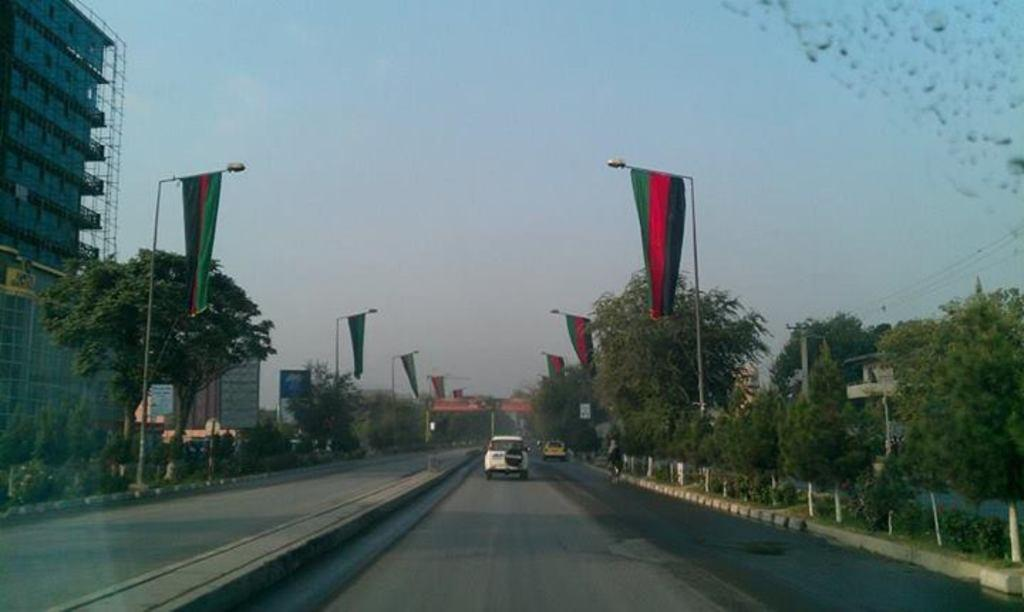What can be seen on the road in the image? There are vehicles on the road in the image. What type of vegetation is present in the image? There are trees in the image. What are the flags attached to in the image? The flags are attached to poles in the image. What type of structures can be seen in the image? There are buildings in the image. What is visible in the background of the image? The sky is visible in the background of the image. Where is the playground located in the image? There is no playground present in the image. What month is it in the image? The month cannot be determined from the image, as there is no information about the time of year. 